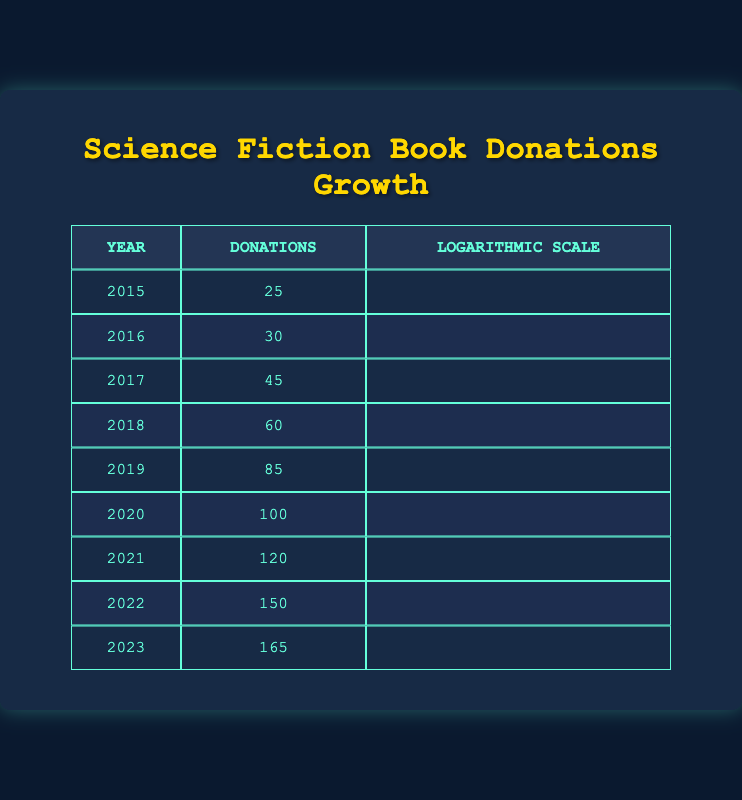What was the total number of science fiction book donations from 2015 to 2019? To find the total donations from 2015 to 2019, we need to add the donations for each year within that range. The donations are: 25 (2015) + 30 (2016) + 45 (2017) + 60 (2018) + 85 (2019). So, 25 + 30 + 45 + 60 + 85 = 245.
Answer: 245 What year had the highest number of donations? Looking at the table, we need to identify the maximum value in the "Donations" column. The highest value is 165, which corresponds to the year 2023.
Answer: 2023 Did the donations increase every year from 2015 to 2023? By examining the "Donations" column year by year: 25 (2015) < 30 (2016) < 45 (2017) < 60 (2018) < 85 (2019) < 100 (2020) < 120 (2021) < 150 (2022) < 165 (2023). Since every year shows an increase, the answer is yes.
Answer: Yes What was the average number of donations per year from 2020 to 2023? The years range from 2020 to 2023, which means we have 4 data points: 100 (2020), 120 (2021), 150 (2022), and 165 (2023). We sum these values: 100 + 120 + 150 + 165 = 635, and then divide by the number of years, which is 4: 635 / 4 = 158.75.
Answer: 158.75 How much did the donations grow from 2015 to 2021? To find the growth in donations, subtract the donations of 2015 (25) from those of 2021 (120). Thus, growth = 120 - 25 = 95.
Answer: 95 What percentage of the total donations in 2023 compared to 2020? The donations in 2023 are 165, and for 2020, they are 100. To find the percentage, use the formula: (165 / 100) * 100%. This gives us 165%.
Answer: 165% Was the increase in donations from 2019 to 2023 greater than 40? The donation amounts are 85 in 2019 and 165 in 2023. The increase is calculated as 165 - 85 = 80. Since 80 is greater than 40, the answer is yes.
Answer: Yes What year had the greatest increase in donations compared to the previous year? We need to find the difference in donations between each consecutive year and see which is the largest: 2015-2016 (5), 2016-2017 (15), 2017-2018 (15), 2018-2019 (25), 2019-2020 (15), 2020-2021 (20), 2021-2022 (30), 2022-2023 (15). The greatest increase occurred between 2021 and 2022 with 30 donations.
Answer: 2022 